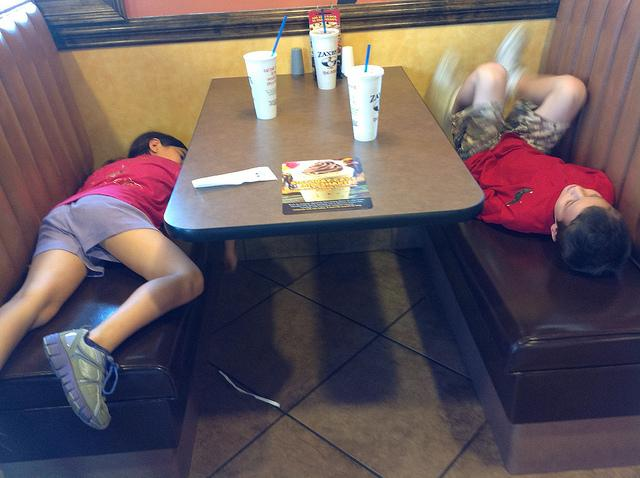Who will pay for this meal? Please explain your reasoning. parent. The children are too young to pay for their own meal. the parent will likely pay. 